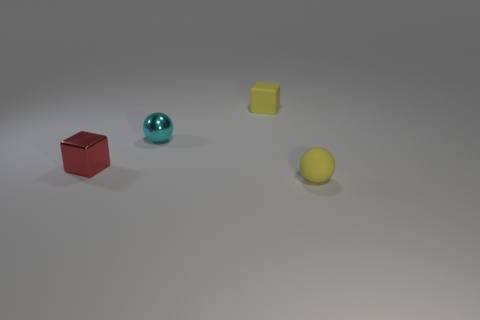Add 2 red metal things. How many objects exist? 6 Add 3 cyan metallic cylinders. How many cyan metallic cylinders exist? 3 Subtract 0 brown cylinders. How many objects are left? 4 Subtract all small metal blocks. Subtract all tiny cubes. How many objects are left? 1 Add 2 yellow objects. How many yellow objects are left? 4 